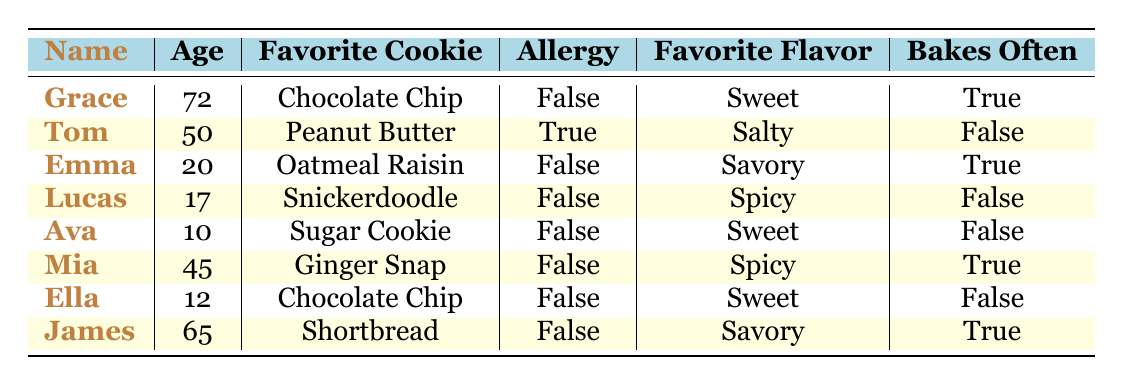What is Grace's favorite cookie? Grace's row in the table states her favorite cookie as "Chocolate Chip."
Answer: Chocolate Chip How many family members have a favorite cookie that is sweet? Checking the favorite cookies, we see that Grace, Ava, and Ella all have cookies categorized as sweet. This gives us a total of 3 family members.
Answer: 3 Does Tom have an allergy? The table indicates that Tom has an allergy listed as true.
Answer: Yes Which family member bakes often and has a savory favorite flavor? Mia and James both bake often, but only James has a favorite flavor of "Savory." So, James is the correct answer.
Answer: James What is the average age of family members who bake often? The ages of family members who bake often are Grace (72), Emma (20), Mia (45), and James (65). Adding these gives 72 + 20 + 45 + 65 = 202. There are 4 individuals, so 202 / 4 = 50.5.
Answer: 50.5 Which cookie flavor is the favorite for the youngest family member? The youngest family member is Ava, who has a favorite cookie of "Sugar Cookie," which is sweet.
Answer: Sweet How many family members have a preference for spicy cookies? From the table, we see Mia (Ginger Snap) and Lucas (Snickerdoodle) have spicy as their favorite flavor. So, there are 2 family members.
Answer: 2 Is there anyone who has an allergy and bakes often? Checking the table reveals that Tom has an allergy but does not bake often, while Mia and Grace bake often with no allergies. Thus, there is no family member with both an allergy and who bakes often.
Answer: No What percentage of family members have a favorite cookie that is chocolate chip? The favorite cookie for Ella and Grace is chocolate chip. There are 8 family members total, so (2 / 8) * 100 = 25%.
Answer: 25% 